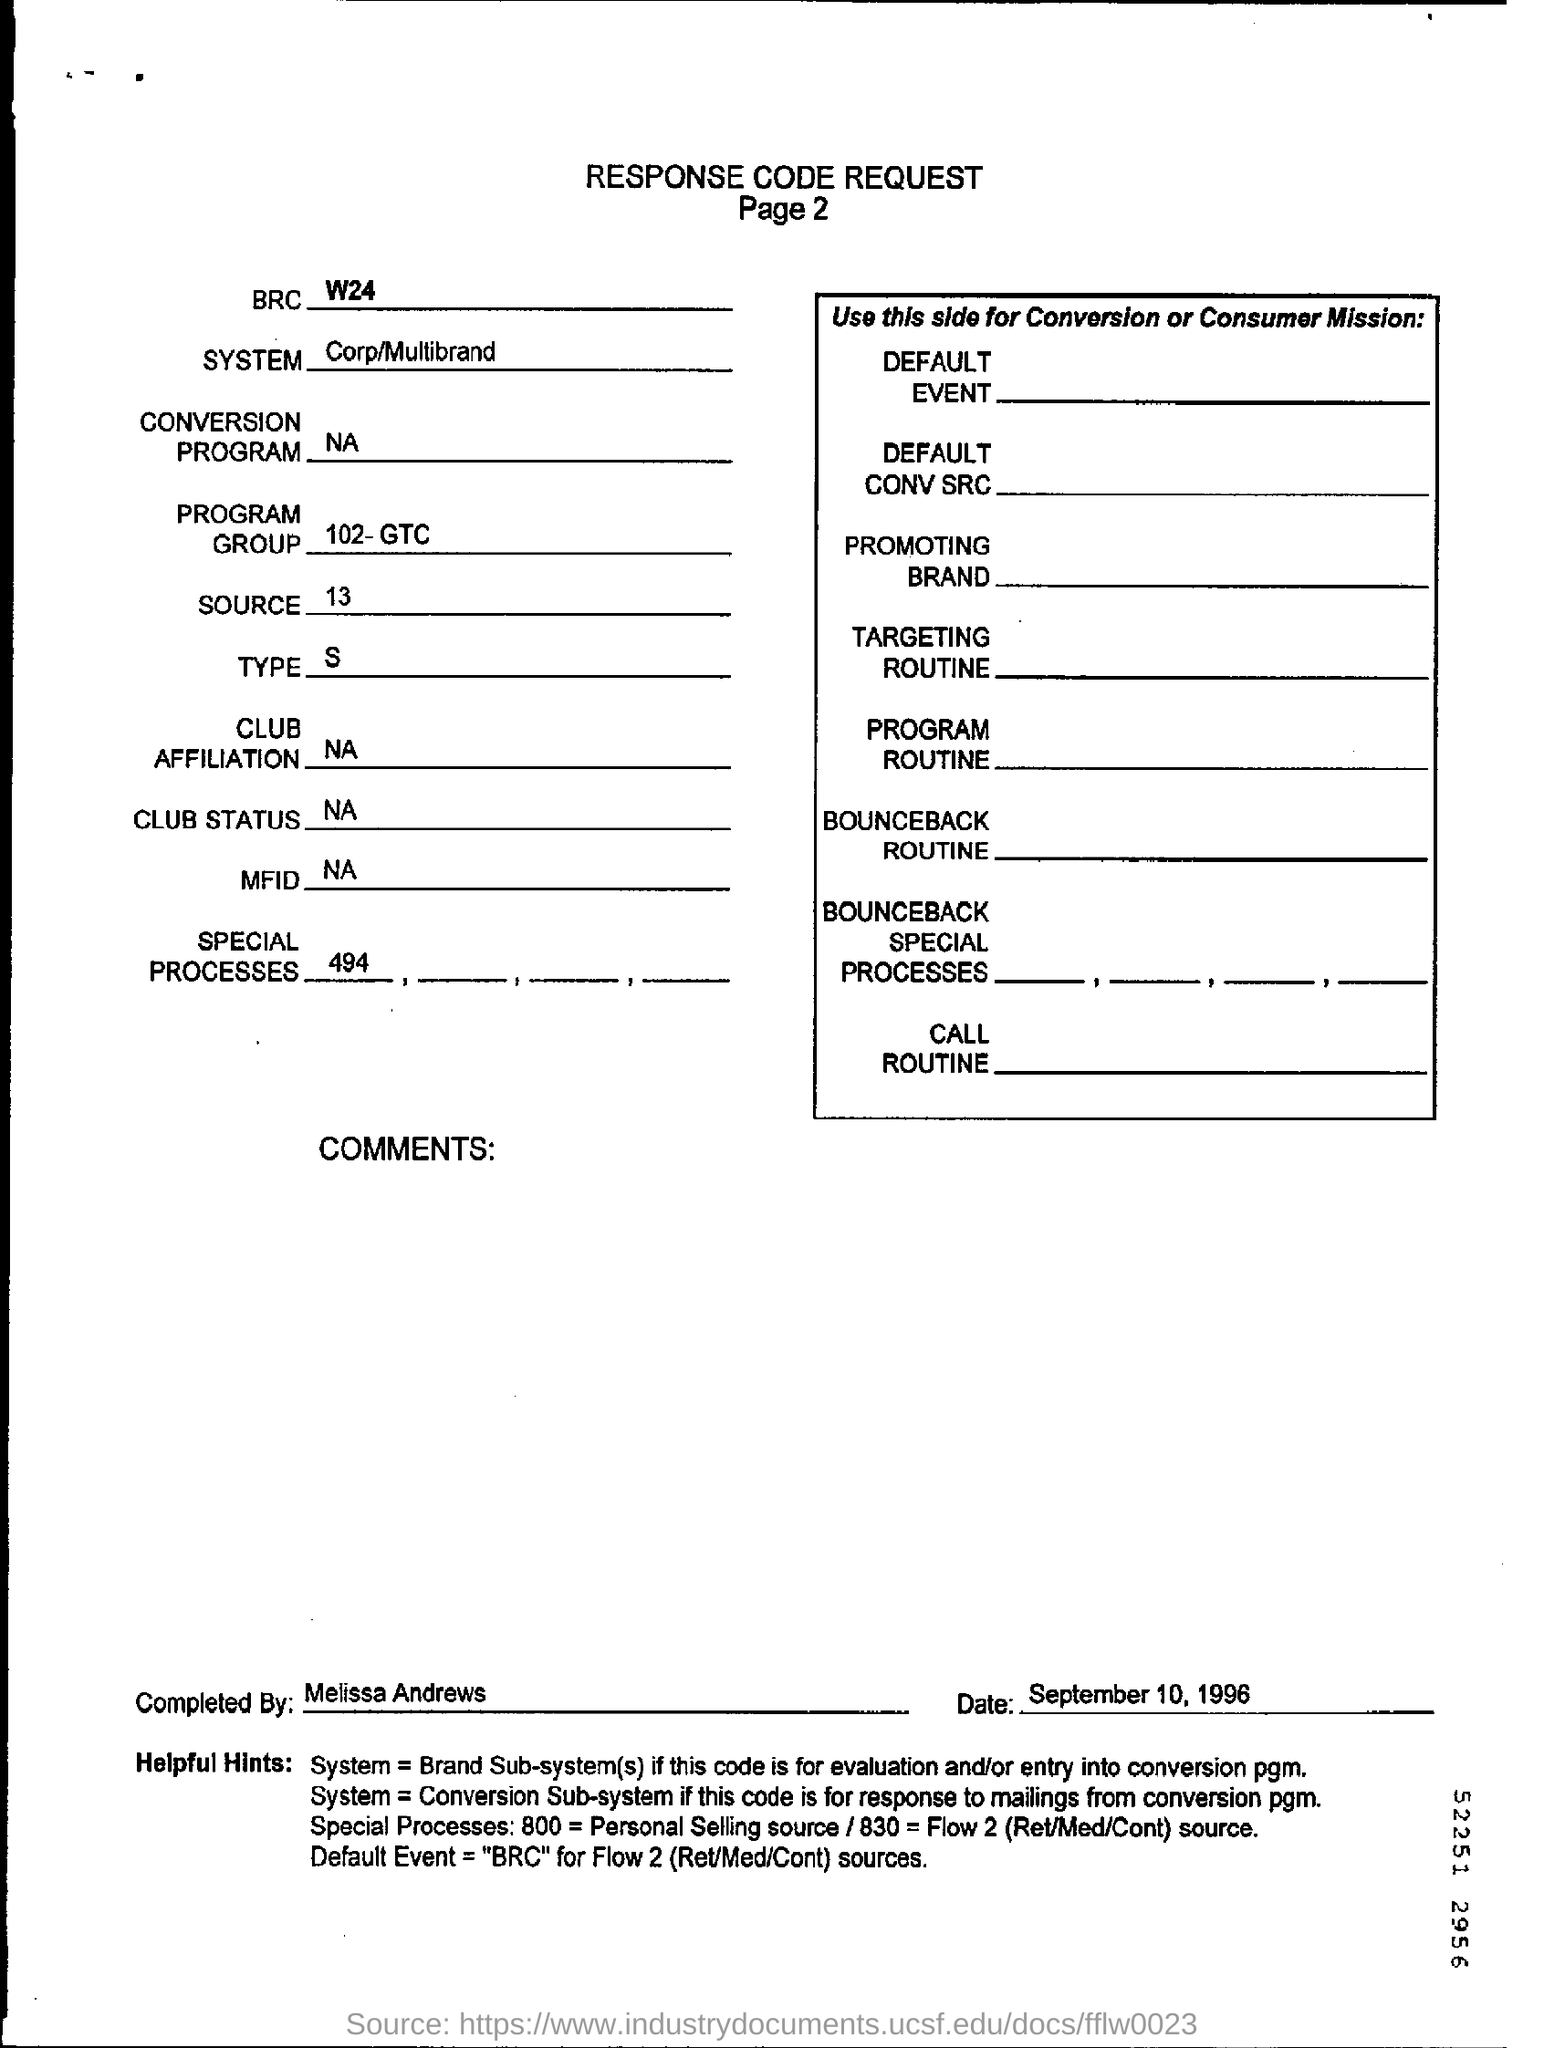Who completed response code request form?
Your answer should be very brief. Melissa Andrews. When is the response code request form dated?
Keep it short and to the point. September 10, 1996. 